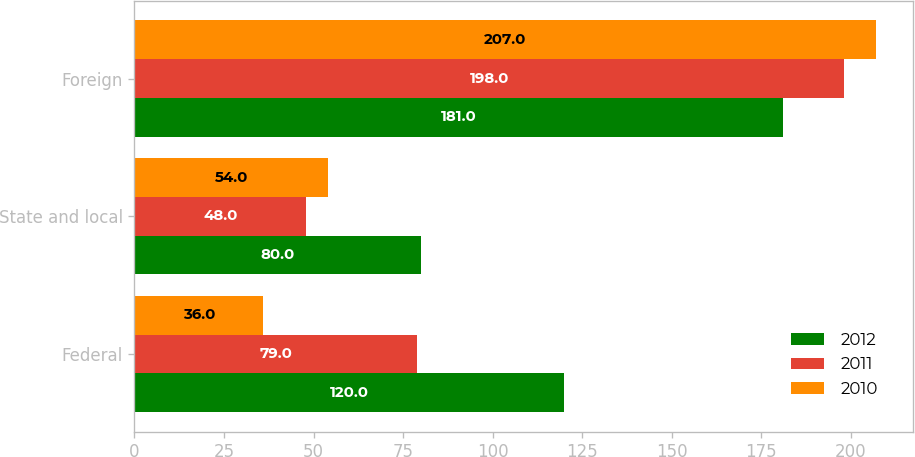Convert chart. <chart><loc_0><loc_0><loc_500><loc_500><stacked_bar_chart><ecel><fcel>Federal<fcel>State and local<fcel>Foreign<nl><fcel>2012<fcel>120<fcel>80<fcel>181<nl><fcel>2011<fcel>79<fcel>48<fcel>198<nl><fcel>2010<fcel>36<fcel>54<fcel>207<nl></chart> 